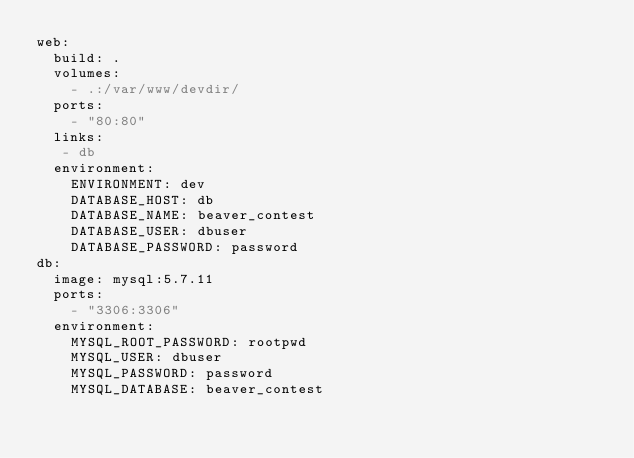<code> <loc_0><loc_0><loc_500><loc_500><_YAML_>web:
  build: .
  volumes:
    - .:/var/www/devdir/
  ports:
    - "80:80"
  links:
   - db
  environment:
    ENVIRONMENT: dev
    DATABASE_HOST: db
    DATABASE_NAME: beaver_contest
    DATABASE_USER: dbuser
    DATABASE_PASSWORD: password
db:
  image: mysql:5.7.11
  ports:
    - "3306:3306"
  environment:
    MYSQL_ROOT_PASSWORD: rootpwd
    MYSQL_USER: dbuser
    MYSQL_PASSWORD: password
    MYSQL_DATABASE: beaver_contest
</code> 